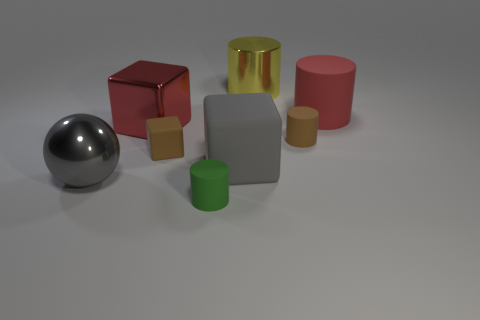Does the ball have the same color as the large rubber cylinder?
Provide a succinct answer. No. What is the size of the brown thing that is to the left of the brown matte object that is right of the cylinder that is behind the big red cylinder?
Offer a very short reply. Small. What number of other objects are the same size as the gray cube?
Provide a succinct answer. 4. What number of tiny cylinders have the same material as the brown block?
Ensure brevity in your answer.  2. What shape is the large shiny thing that is in front of the small brown rubber cylinder?
Provide a short and direct response. Sphere. Are the large ball and the large red block that is behind the big gray rubber block made of the same material?
Offer a very short reply. Yes. Are any red matte things visible?
Give a very brief answer. Yes. Is there a shiny cylinder that is in front of the small brown matte object on the right side of the tiny matte cylinder on the left side of the large gray rubber thing?
Provide a succinct answer. No. How many tiny objects are either rubber cylinders or brown cylinders?
Ensure brevity in your answer.  2. What color is the other rubber block that is the same size as the red block?
Your answer should be compact. Gray. 